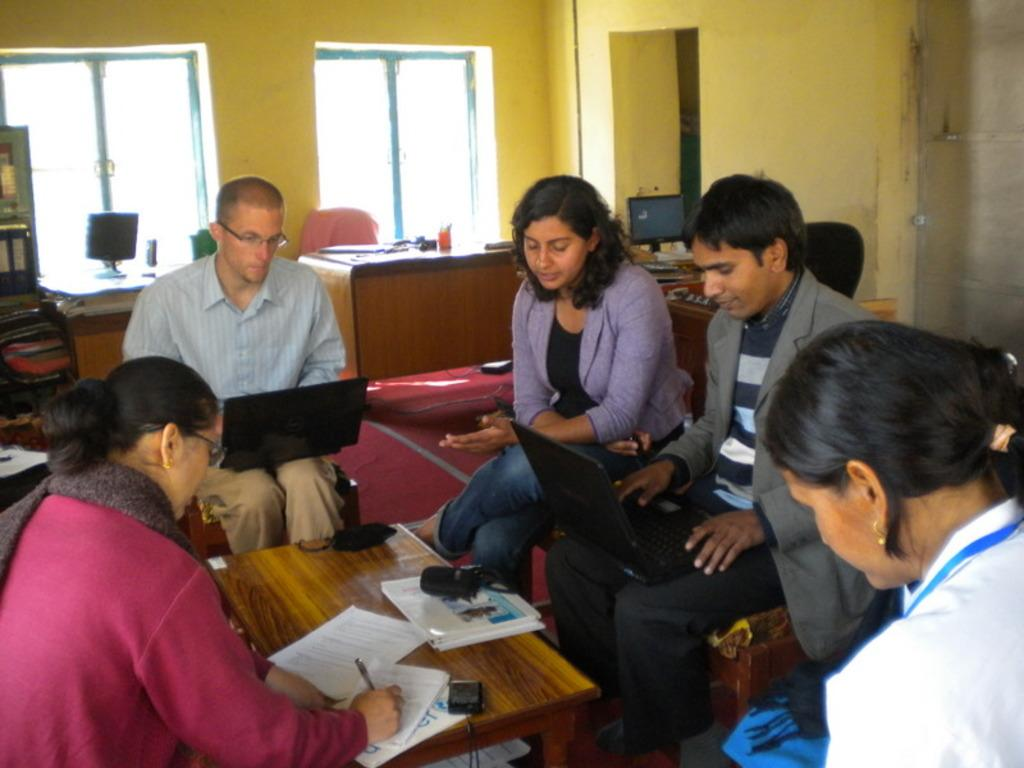How many people are in the image? There is a group of persons in the image. What are the persons doing in the image? The persons are sitting in chairs. What is on the table in the image? There are pens and papers on the table. What can be seen in the background of the image? There is a computer, a rack, and a window in the background. Reasoning: Let'g: Let's think step by step in order to produce the conversation. We start by identifying the main subject in the image, which is the group of persons. Then, we describe their actions and the objects they are interacting with, such as the chairs, table, pens, and papers. Finally, we expand the conversation to include the background elements, including the computer, rack, and window. Absurd Question/Answer: What type of skate is being used by the persons in the image? There is no skate present in the image; the persons are sitting in chairs. How does the sponge help the persons in the image? There is no sponge present in the image, so it cannot help the persons in any way. 